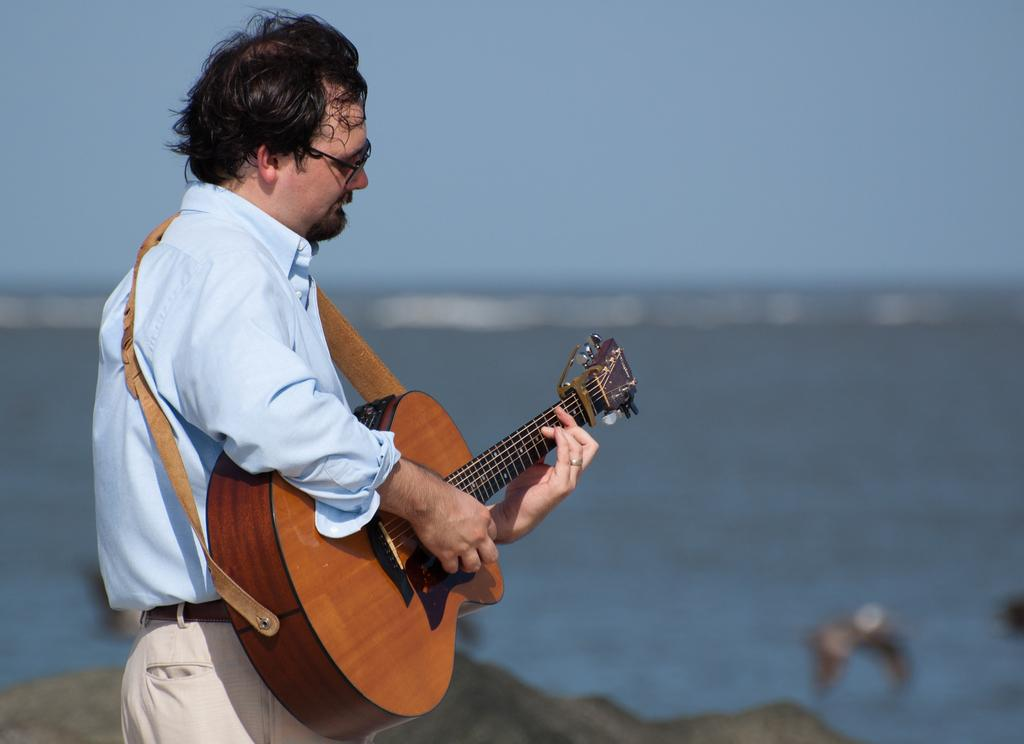What is the main subject of the image? There is a man in the image. What is the man doing in the image? The man is standing and playing a guitar. What can be seen in the background of the image? There is water and a sky visible in the background of the image. What type of attraction can be seen in the image? There is no attraction present in the image; it features a man playing a guitar. What type of humor is being displayed by the man in the image? There is no humor being displayed by the man in the image; he is simply playing a guitar. 